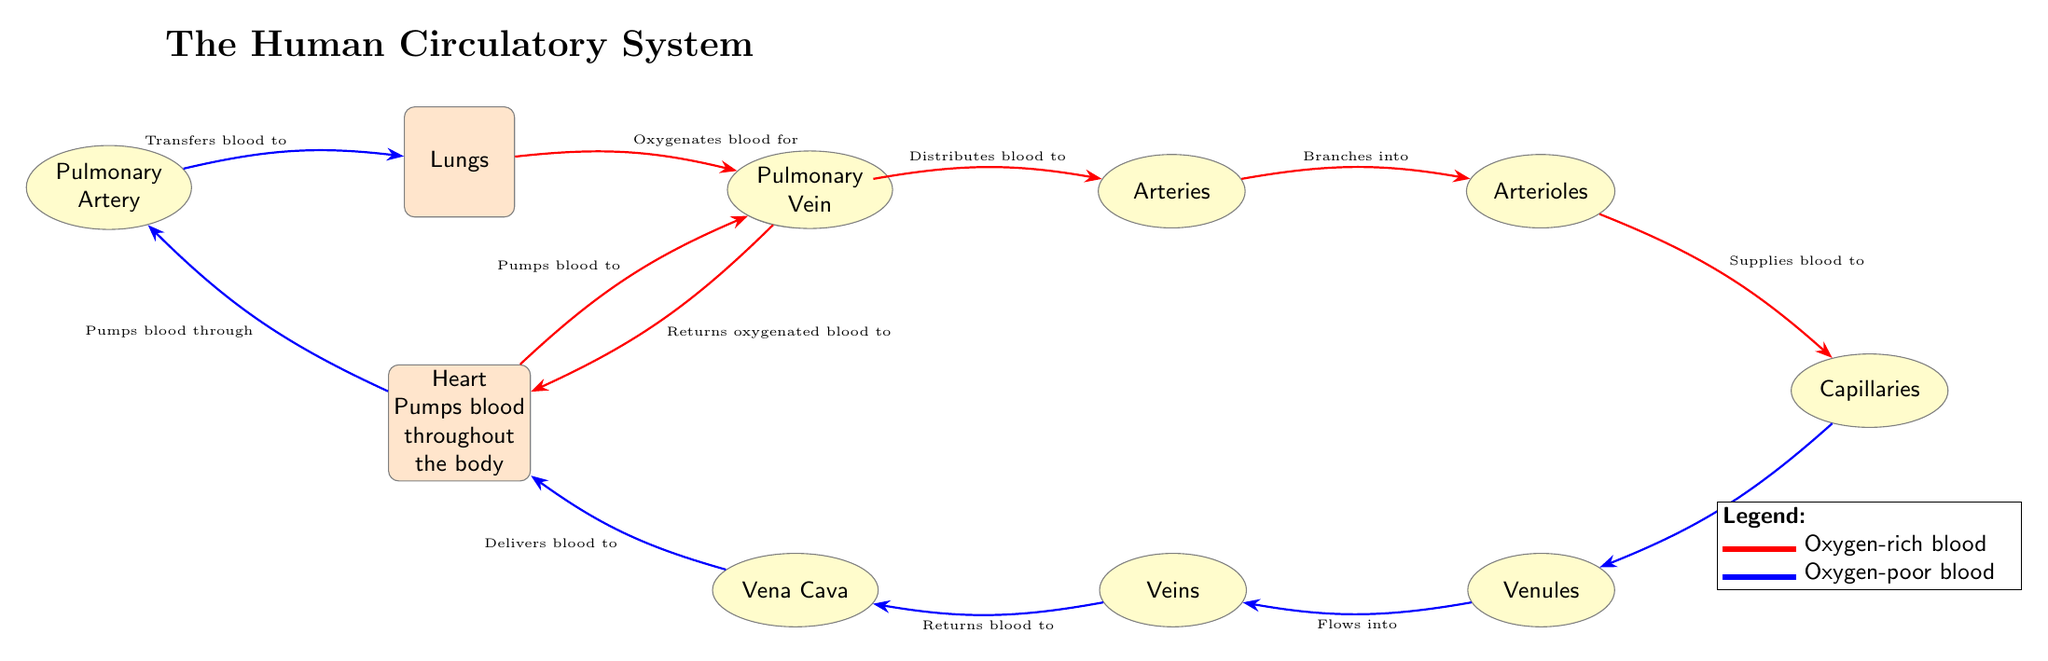What is the main organ that pumps blood throughout the body? The diagram clearly labels the node for the heart, which states "Heart\\Pumps blood\\throughout\\the body." Therefore, the main organ that pumps blood is the heart.
Answer: Heart How many types of blood vessels are shown in the diagram? The diagram includes five types of blood vessels: Aorta, Arteries, Arterioles, Capillaries, Venules, Veins, and Vena Cava. Counting these, we find there are a total of seven types labeled.
Answer: Seven What color represents oxygen-rich blood? The diagram provides a legend indicating that the color red is used to represent oxygen-rich blood. This is shown by the red color coding applied to the connections associated with oxygenated blood.
Answer: Red What is the flow of blood from the heart to the lungs, according to the diagram? The diagram indicates that blood flows from the heart to the pulmonary artery, which then transfers blood to the lungs. This sequence illustrates the pathway of blood to be oxygenated.
Answer: Heart to Pulmonary Artery to Lungs Which blood vessel returns oxygen-poor blood to the heart? The diagram illustrates that the vena cava is responsible for returning oxygen-poor blood to the heart, as indicated by the pathway leading from veins to vena cava to the heart.
Answer: Vena Cava What is the role of capillaries in the circulatory system? Capillaries are depicted as the vessels that supply blood to tissues, connecting arterioles and venules. They play a critical role in exchanging oxygen and nutrients with cells.
Answer: Supply blood to tissues Which organ oxygenates the blood before it returns to the heart? From the diagram, the lungs are specified as the organ that oxygenates blood before it returns to the heart, as shown in the pathway from the pulmonary vein back to the heart after oxygenation.
Answer: Lungs In what direction does the blood flow from the capillaries according to the diagram? The diagram illustrates that blood drains from the capillaries into venules, which then flows into veins. This shows the pathway that blood takes after delivering oxygen to tissues.
Answer: Drains into Venules What is the significance of the color coding used in the diagram? The color coding distinguishes between two types of blood: red for oxygen-rich blood and blue for oxygen-poor blood. This visual differentiation helps in understanding the flow and function of blood throughout the circulatory system.
Answer: Differentiates blood types 